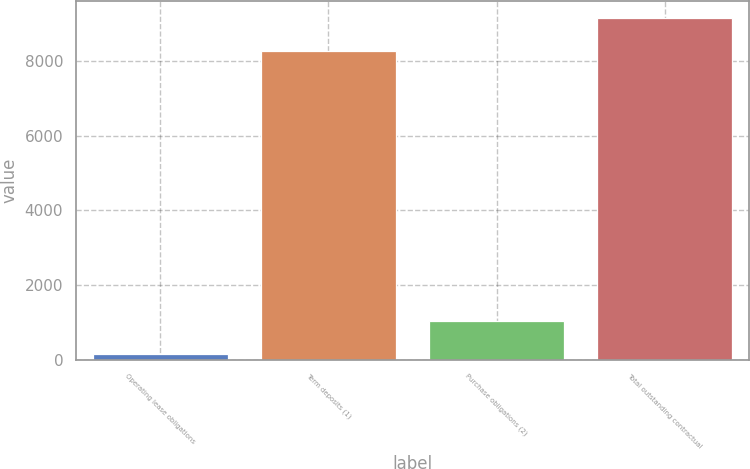Convert chart. <chart><loc_0><loc_0><loc_500><loc_500><bar_chart><fcel>Operating lease obligations<fcel>Term deposits (1)<fcel>Purchase obligations (2)<fcel>Total outstanding contractual<nl><fcel>162<fcel>8278<fcel>1039.9<fcel>9155.9<nl></chart> 